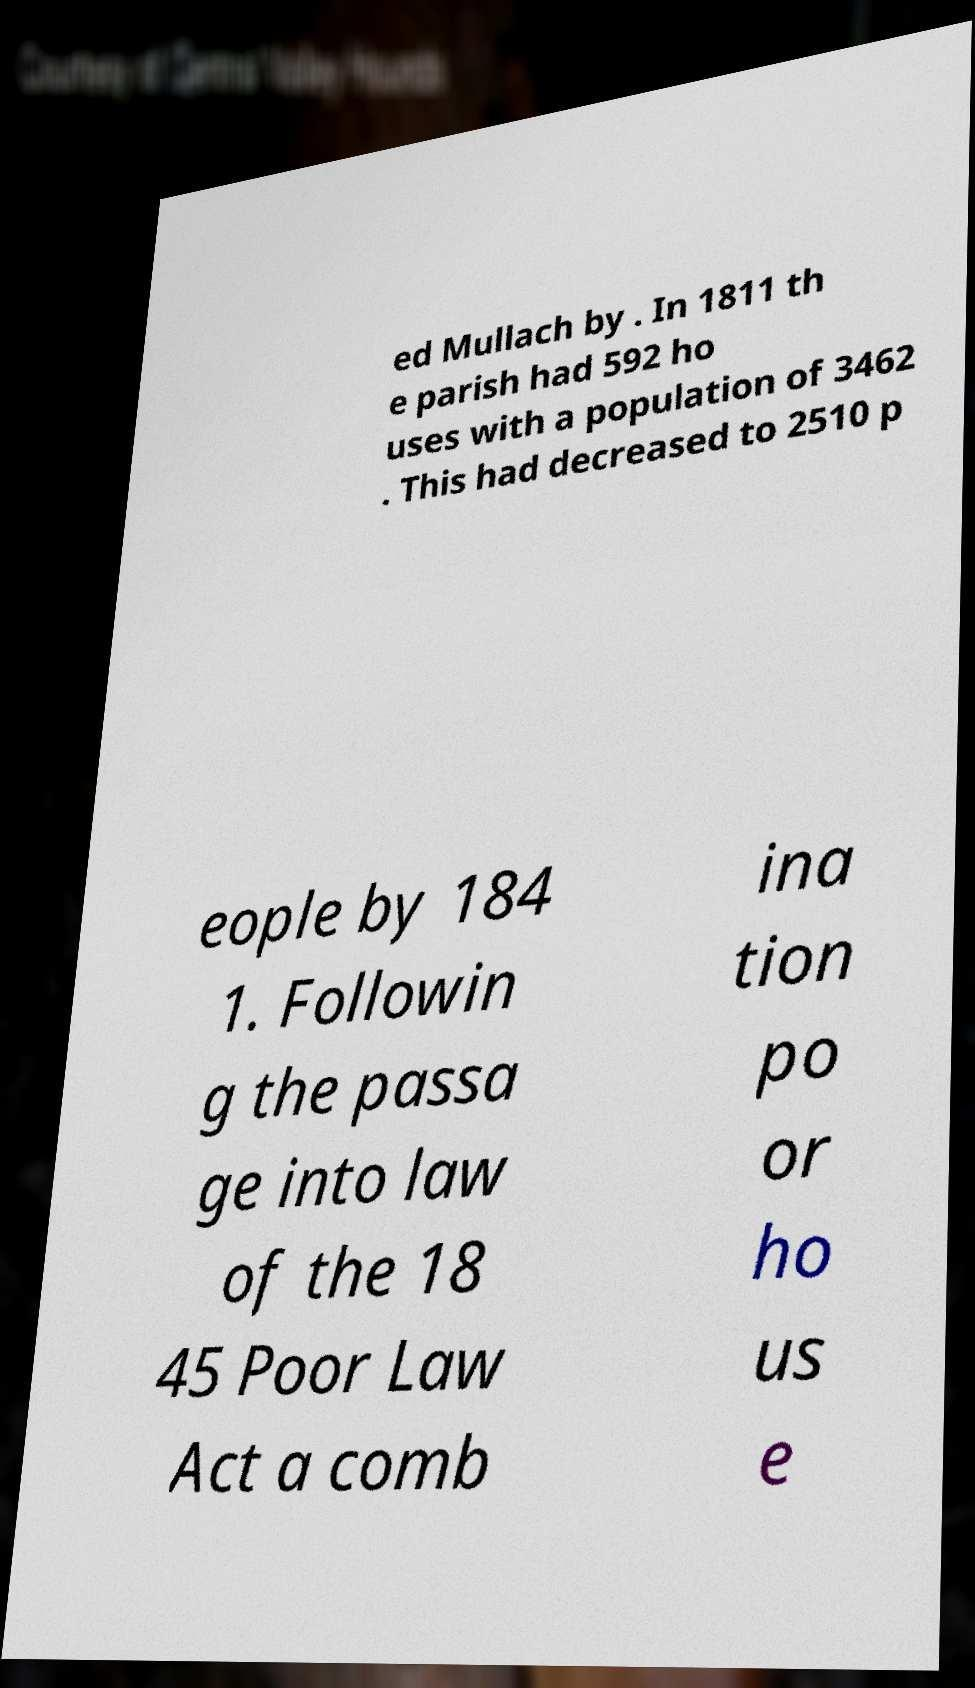Please read and relay the text visible in this image. What does it say? ed Mullach by . In 1811 th e parish had 592 ho uses with a population of 3462 . This had decreased to 2510 p eople by 184 1. Followin g the passa ge into law of the 18 45 Poor Law Act a comb ina tion po or ho us e 